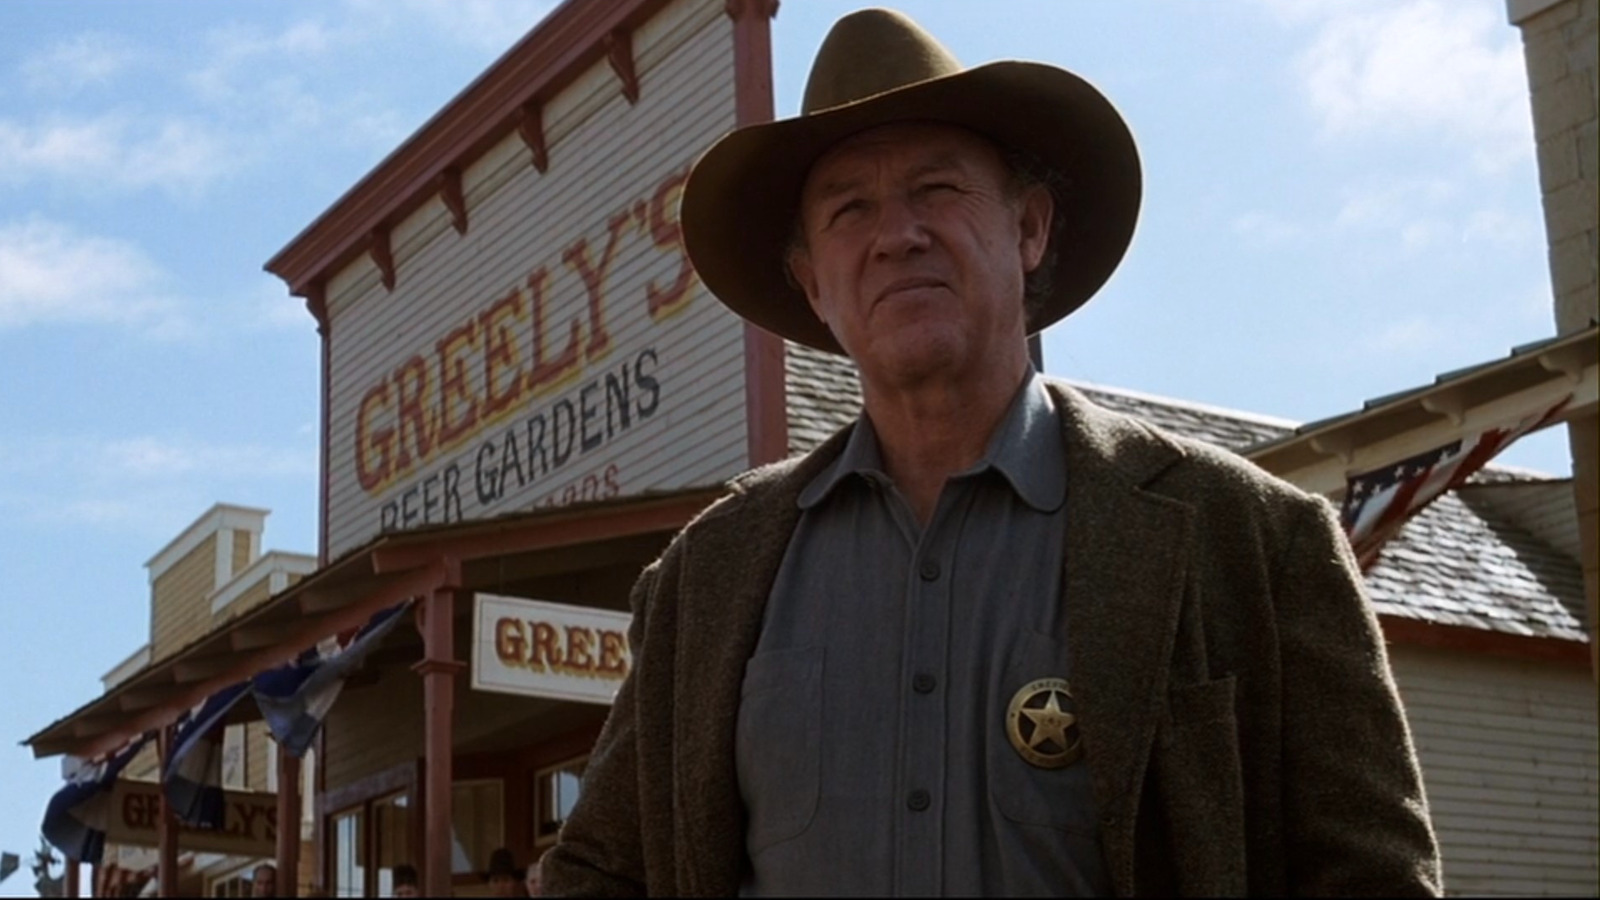Create a story that might lead up to this moment in the image. In the frontier town of Dry Creek, Sheriff sharegpt4v/sam Greeley was known for his tough but fair approach to law enforcement. The day began like any other, the sun rising over the dusty streets with townsfolk going about their daily chores. Suddenly, a gang of outlaws rode into town, disrupting the peace. Sheriff Greeley, alerted by the commotion, hurriedly donned his hat and jacket, pinned his badge, and stepped outside. Standing resolutely in front of 'Greeley's Beer Gardens,' he scanned the horizon, knowing that a confrontation was inevitable. His stern gaze and firm posture reflected his readiness to protect the town, no matter the cost. 